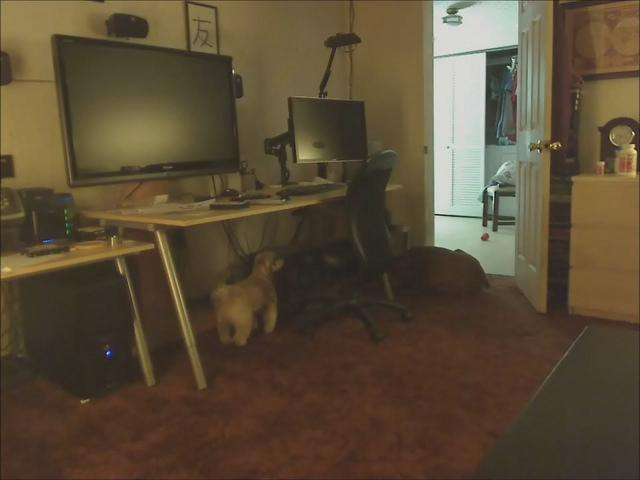The thing that is under the desk belongs to what family? canidae 